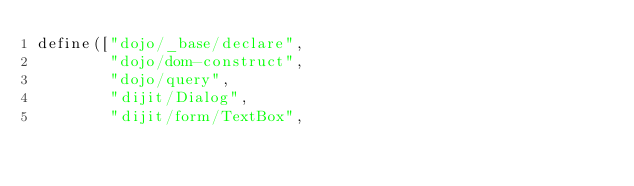Convert code to text. <code><loc_0><loc_0><loc_500><loc_500><_JavaScript_>define(["dojo/_base/declare",
        "dojo/dom-construct",
        "dojo/query",
        "dijit/Dialog",
        "dijit/form/TextBox",</code> 